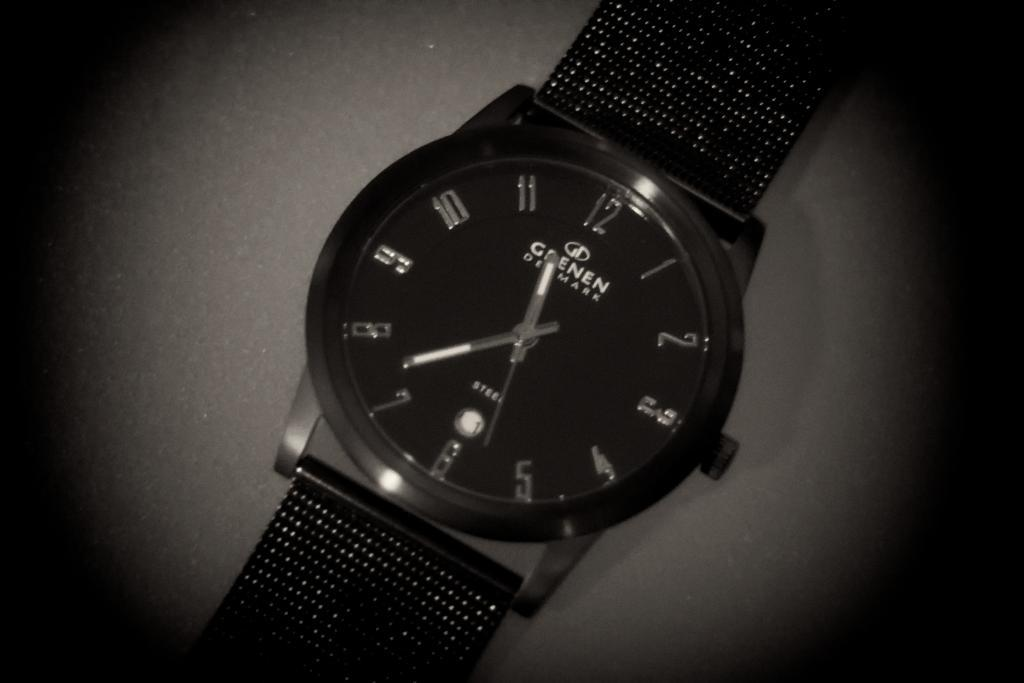<image>
Offer a succinct explanation of the picture presented. Grenen Denmark women's watch with steel mesh straps, winding button on side. 